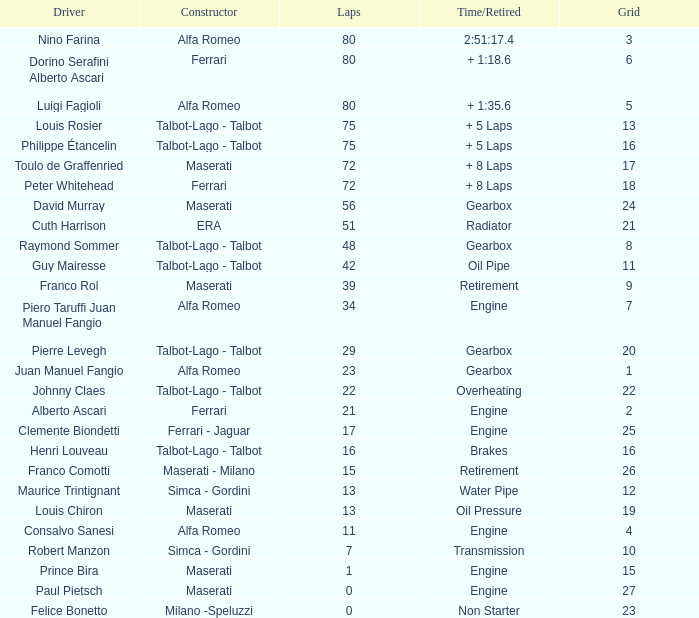When grid is less than 7, laps are greater than 17, and time/retired is + 1:35.6, who is the constructor? Alfa Romeo. 